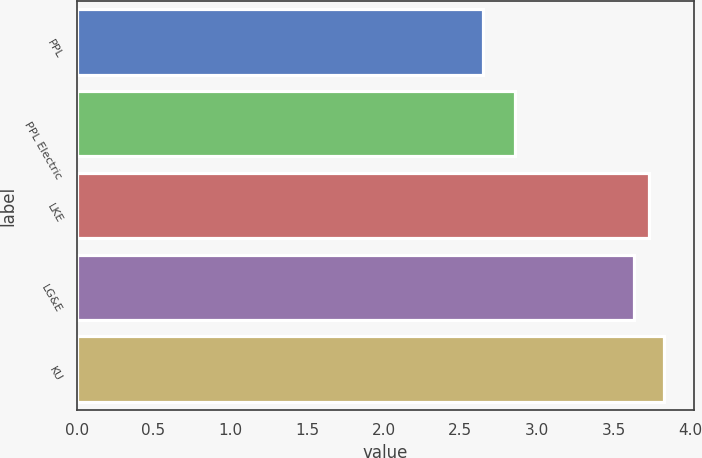Convert chart to OTSL. <chart><loc_0><loc_0><loc_500><loc_500><bar_chart><fcel>PPL<fcel>PPL Electric<fcel>LKE<fcel>LG&E<fcel>KU<nl><fcel>2.65<fcel>2.86<fcel>3.73<fcel>3.63<fcel>3.83<nl></chart> 